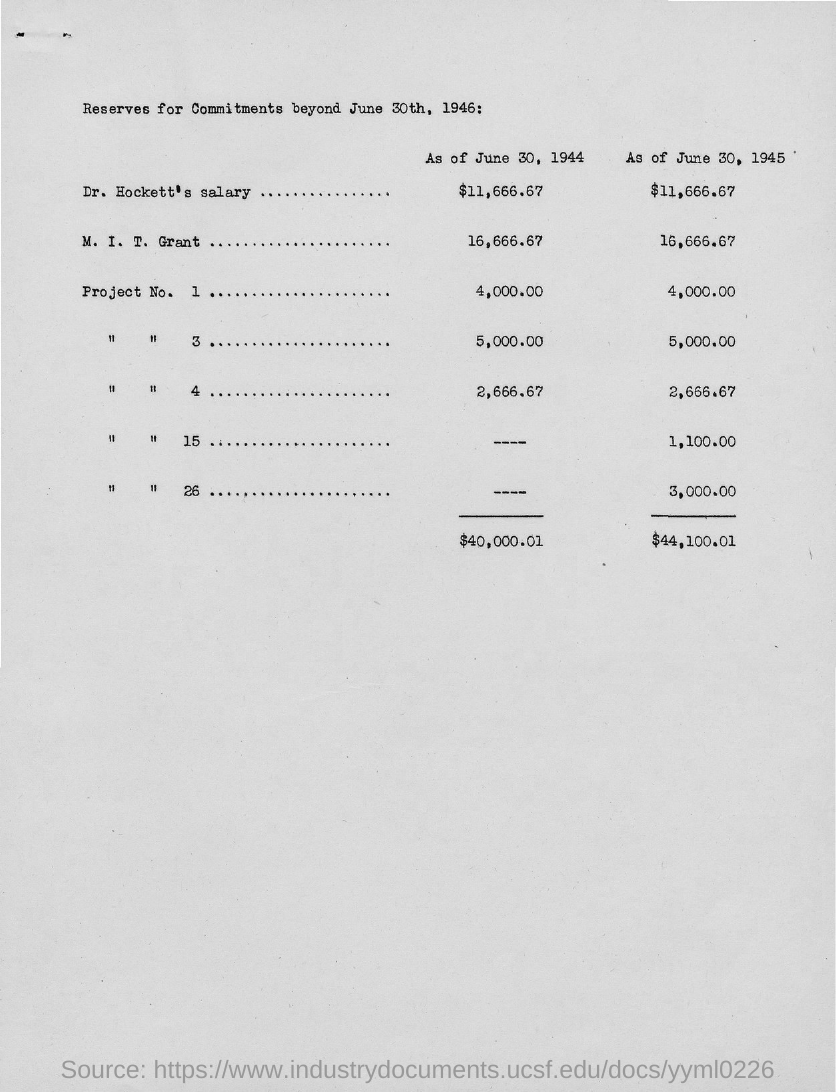What is Dr. Hockett's salary as of June 30, 1944?
Provide a short and direct response. $11,666.67. What is the M. I. T. Grant amount as of June 30, 1945?
Keep it short and to the point. $16,666.67. What is Dr. Hockett's salary as of June 30, 1945?
Keep it short and to the point. $11,666.67. 